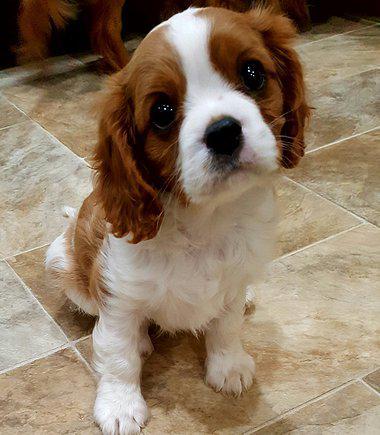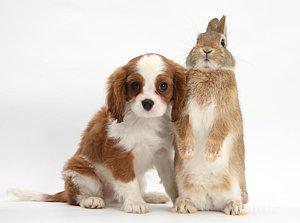The first image is the image on the left, the second image is the image on the right. Evaluate the accuracy of this statement regarding the images: "An image shows a brown and white spaniel posed next to another animal.". Is it true? Answer yes or no. Yes. The first image is the image on the left, the second image is the image on the right. Considering the images on both sides, is "One image features two animals, although one may not be a puppy, on a plain background." valid? Answer yes or no. Yes. 